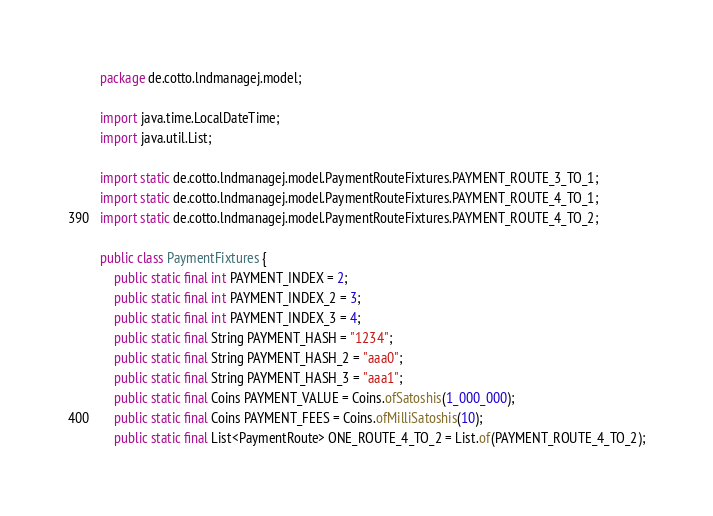<code> <loc_0><loc_0><loc_500><loc_500><_Java_>package de.cotto.lndmanagej.model;

import java.time.LocalDateTime;
import java.util.List;

import static de.cotto.lndmanagej.model.PaymentRouteFixtures.PAYMENT_ROUTE_3_TO_1;
import static de.cotto.lndmanagej.model.PaymentRouteFixtures.PAYMENT_ROUTE_4_TO_1;
import static de.cotto.lndmanagej.model.PaymentRouteFixtures.PAYMENT_ROUTE_4_TO_2;

public class PaymentFixtures {
    public static final int PAYMENT_INDEX = 2;
    public static final int PAYMENT_INDEX_2 = 3;
    public static final int PAYMENT_INDEX_3 = 4;
    public static final String PAYMENT_HASH = "1234";
    public static final String PAYMENT_HASH_2 = "aaa0";
    public static final String PAYMENT_HASH_3 = "aaa1";
    public static final Coins PAYMENT_VALUE = Coins.ofSatoshis(1_000_000);
    public static final Coins PAYMENT_FEES = Coins.ofMilliSatoshis(10);
    public static final List<PaymentRoute> ONE_ROUTE_4_TO_2 = List.of(PAYMENT_ROUTE_4_TO_2);</code> 